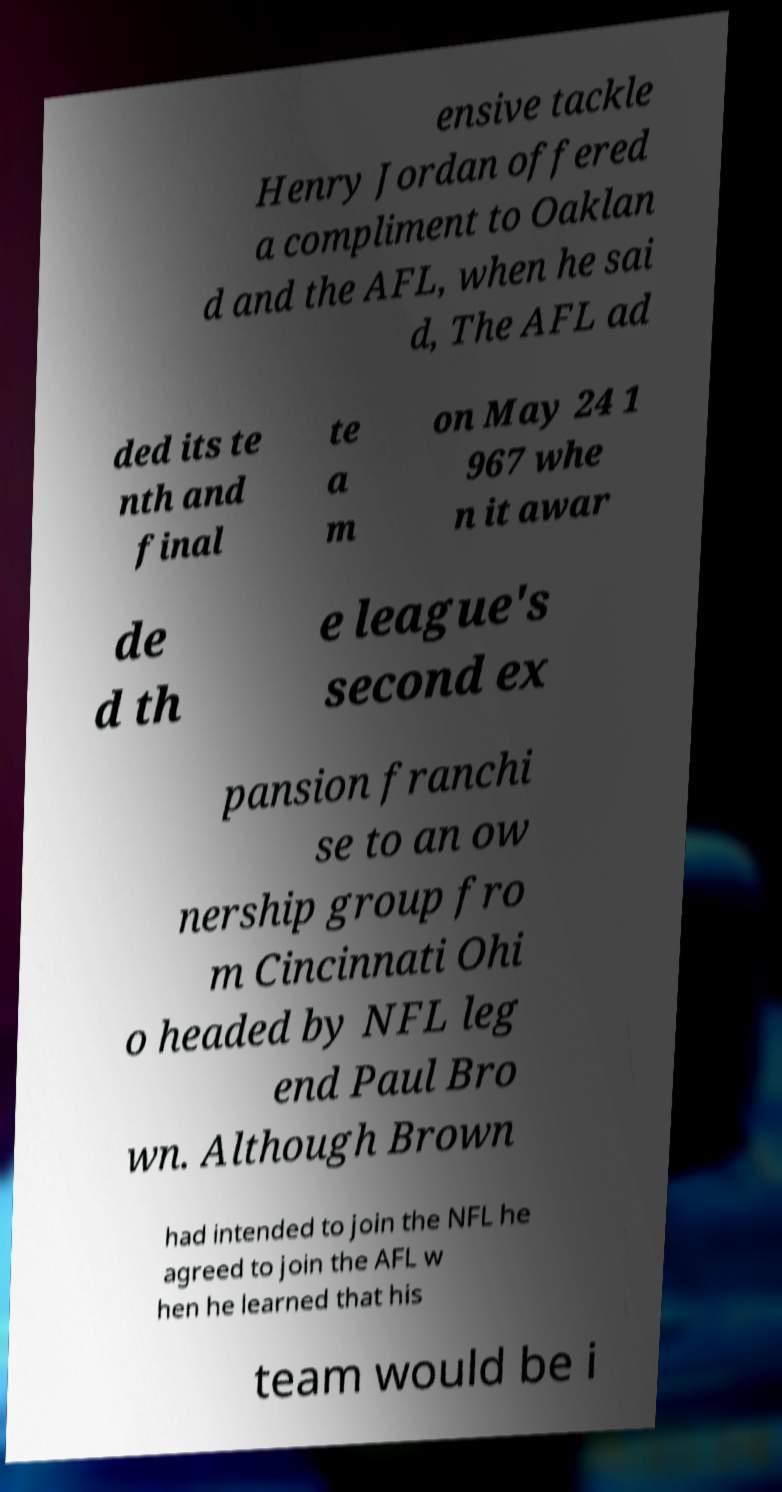Can you accurately transcribe the text from the provided image for me? ensive tackle Henry Jordan offered a compliment to Oaklan d and the AFL, when he sai d, The AFL ad ded its te nth and final te a m on May 24 1 967 whe n it awar de d th e league's second ex pansion franchi se to an ow nership group fro m Cincinnati Ohi o headed by NFL leg end Paul Bro wn. Although Brown had intended to join the NFL he agreed to join the AFL w hen he learned that his team would be i 